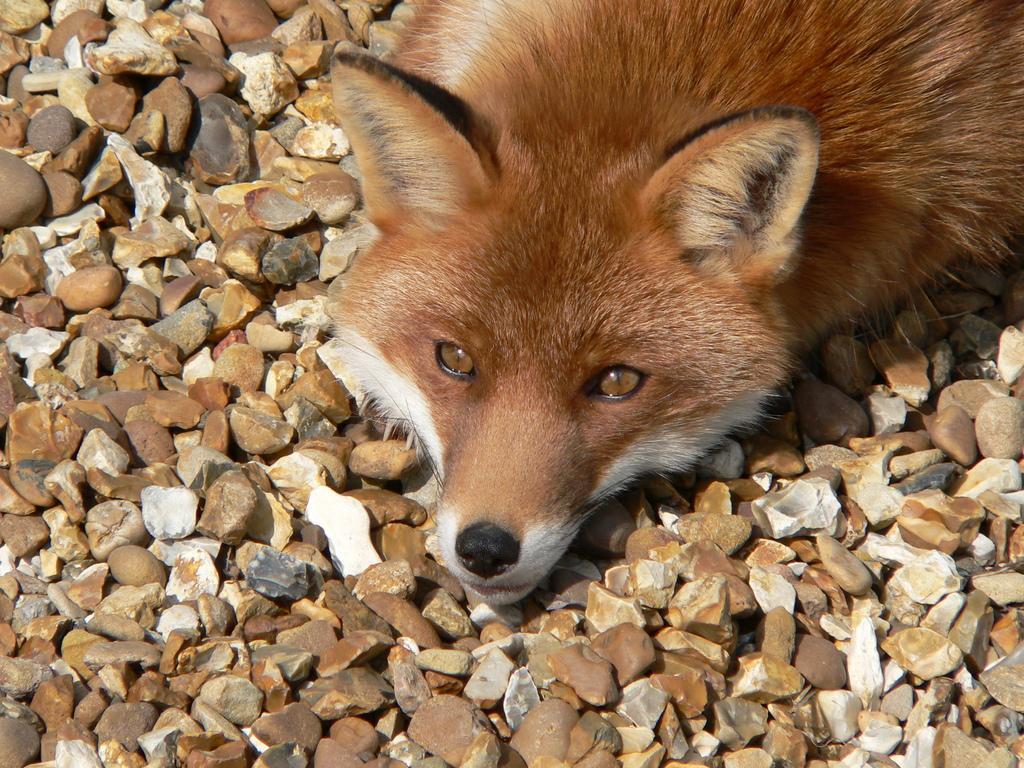Please provide a concise description of this image. In this picture I can see a fox, it is white and brown in color and few small stones on the ground. 